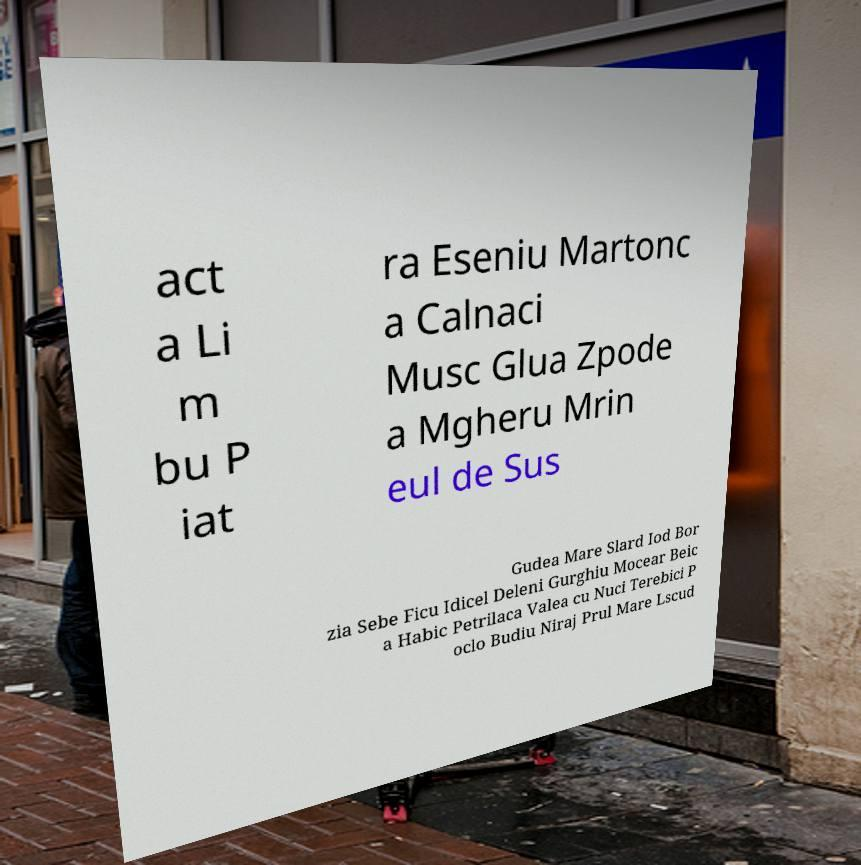Please read and relay the text visible in this image. What does it say? act a Li m bu P iat ra Eseniu Martonc a Calnaci Musc Glua Zpode a Mgheru Mrin eul de Sus Gudea Mare Slard Iod Bor zia Sebe Ficu Idicel Deleni Gurghiu Mocear Beic a Habic Petrilaca Valea cu Nuci Terebici P oclo Budiu Niraj Prul Mare Lscud 